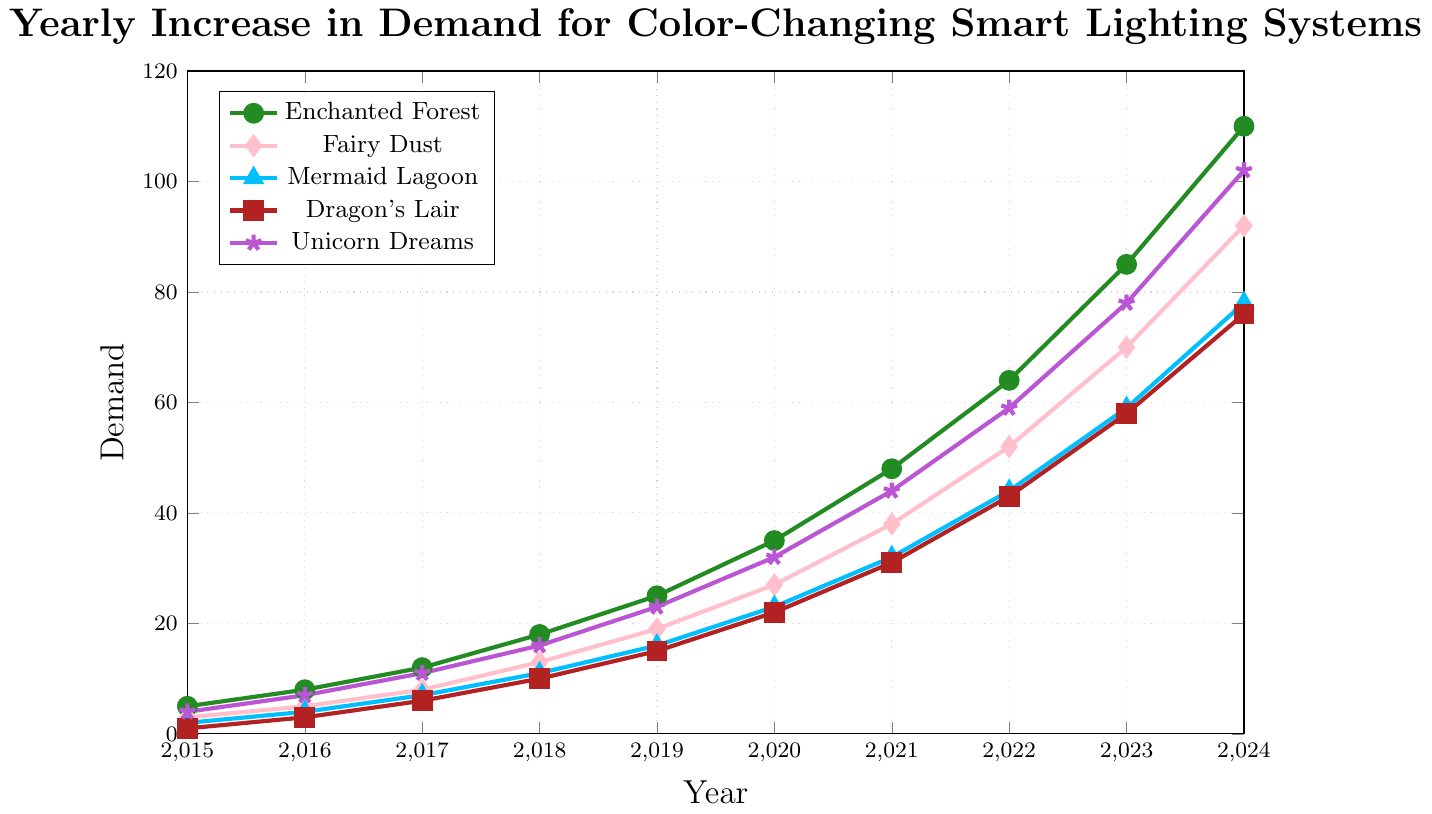What is the highest demand value among all the color palettes in 2024? Look at the demand values for each color palette in 2024, which are Enchanted Forest: 110, Fairy Dust: 92, Mermaid Lagoon: 78, Dragon's Lair: 76, Unicorn Dreams: 102. The highest among these is 110 for Enchanted Forest
Answer: 110 Which color palette saw the greatest absolute increase in demand from 2015 to 2024? Calculate the difference in demand for each color palette from 2015 to 2024. Enchanted Forest: 110 - 5 = 105, Fairy Dust: 92 - 3 = 89, Mermaid Lagoon: 78 - 2 = 76, Dragon's Lair: 76 - 1 = 75, Unicorn Dreams: 102 - 4 = 98. Enchanted Forest has the greatest increase of 105
Answer: Enchanted Forest How does the 2023 demand for "Unicorn Dreams" compare to "Mermaid Lagoon"? Look at the demand values in 2023 for Unicorn Dreams (78) and Mermaid Lagoon (59). Compare 78 and 59: 78 is greater
Answer: Unicorn Dreams has a higher demand than Mermaid Lagoon Which year shows the first instance where "Fairy Dust" demand reaches or exceeds 50? Check each year’s demand value for Fairy Dust until it reaches or exceeds 50. In 2022, Fairy Dust demand is 52, crossing 50 for the first time
Answer: 2022 In what year did the demand for "Dragon's Lair" reach 15 for the first time? Look at the demand values for Dragon's Lair over the years. In 2019, Dragon’s Lair demand reaches 15 for the first time
Answer: 2019 By how much did the demand for "Mermaid Lagoon" increase between 2020 and 2023? The demand for Mermaid Lagoon in 2020 was 23 and in 2023 it was 59. Calculate the difference: 59 - 23 = 36
Answer: 36 Which two color palettes had the closest demand values in 2022, and what was the difference? The demands in 2022 are Enchanted Forest: 64, Fairy Dust: 52, Mermaid Lagoon: 44, Dragon's Lair: 43, Unicorn Dreams: 59. The closest values are Dragon's Lair (43) and Mermaid Lagoon (44) with a difference of 1
Answer: Dragon's Lair and Mermaid Lagoon, 1 What is the average demand for "Enchanted Forest" over the years 2019 to 2021? Look at the demand values for Enchanted Forest from 2019 (25), 2020 (35), and 2021 (48). Calculate the average: (25 + 35 + 48)/3 = 36
Answer: 36 Compare the trend of "Fairy Dust" and "Dragon's Lair" from 2015 to 2020. Which one shows a steeper increase in demand? Look at the demand for Fairy Dust: 3 in 2015 to 27 in 2020. For Dragon's Lair: 1 in 2015 to 22 in 2020. Increase for Fairy Dust: 27 - 3 = 24; for Dragon's Lair: 22 - 1 = 21. Fairy Dust shows a steeper increase
Answer: Fairy Dust What is the total demand for all color palettes in the year 2021? Sum the demand values for all palettes in 2021: Enchanted Forest (48), Fairy Dust (38), Mermaid Lagoon (32), Dragon's Lair (31), Unicorn Dreams (44). Total = 48 + 38 + 32 + 31 + 44 = 193
Answer: 193 